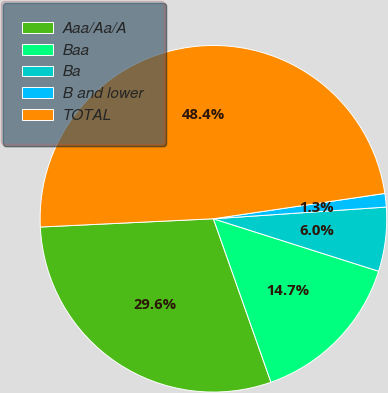Convert chart. <chart><loc_0><loc_0><loc_500><loc_500><pie_chart><fcel>Aaa/Aa/A<fcel>Baa<fcel>Ba<fcel>B and lower<fcel>TOTAL<nl><fcel>29.63%<fcel>14.72%<fcel>5.97%<fcel>1.26%<fcel>48.42%<nl></chart> 